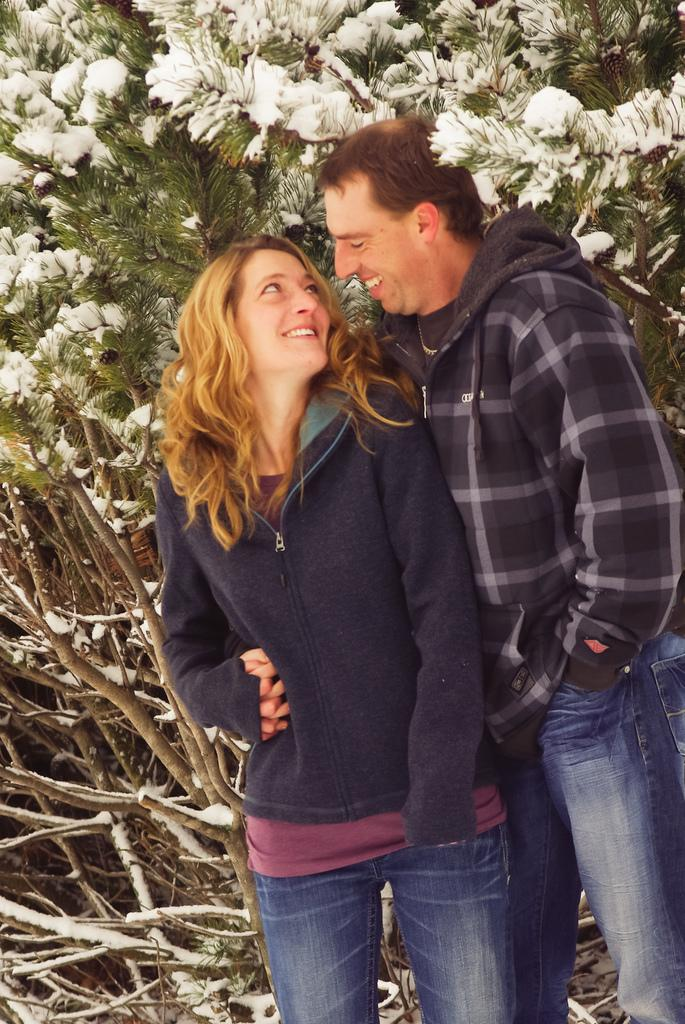How many people are present in the image? There are two people standing in the image. What is the facial expression of the people in the image? The people are smiling. What can be seen in the background of the image? There is snow on the trees in the background of the image. Where is the hall located in the image? There is no hall present in the image. Are the people pointing at each other in the image? The provided facts do not mention any pointing or gesturing between the two people. 